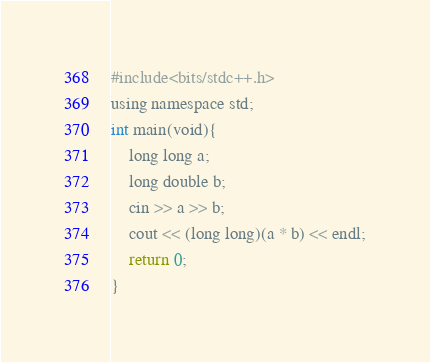<code> <loc_0><loc_0><loc_500><loc_500><_Python_>#include<bits/stdc++.h>
using namespace std;
int main(void){
    long long a;
    long double b;
    cin >> a >> b;
    cout << (long long)(a * b) << endl;
    return 0;
}</code> 